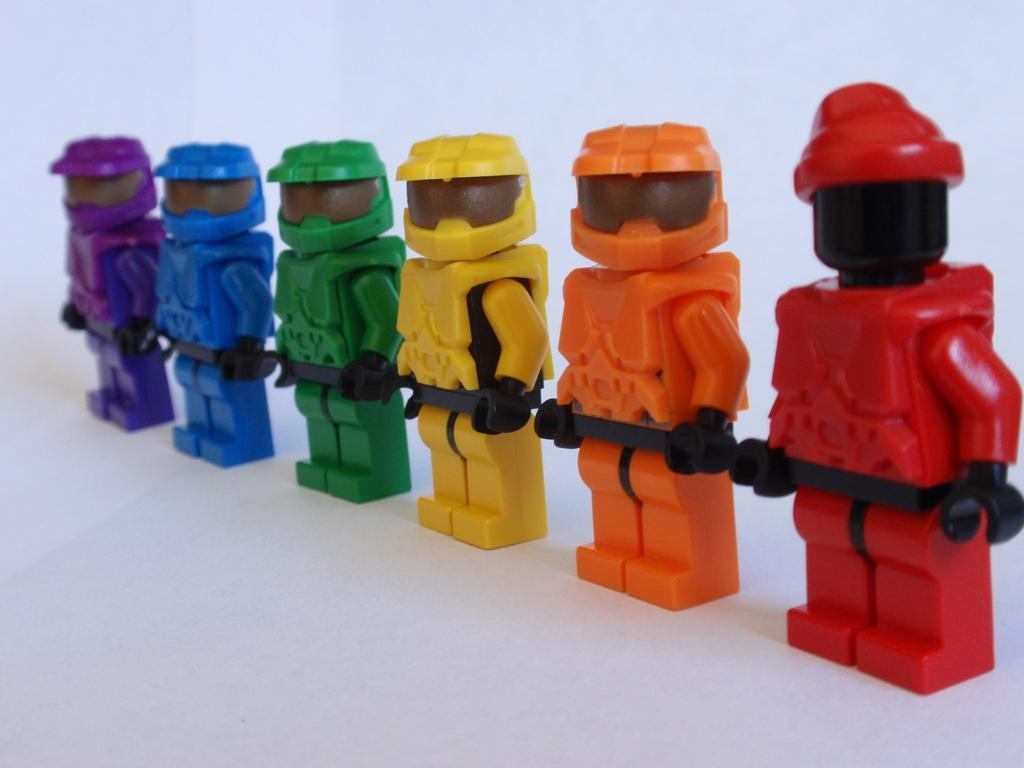What objects can be seen in the image? There are toys in the image. Can you describe the appearance of the toys? The toys are of different colors. Where are the toys placed? The toys are kept on a surface. What is the color of the surface? The surface is white in color. What type of gate can be seen in the image? There is no gate present in the image; it features toys on a white surface. How is the cream being used in the image? There is no cream present in the image. 